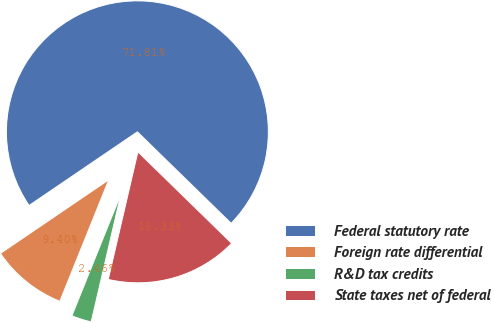Convert chart. <chart><loc_0><loc_0><loc_500><loc_500><pie_chart><fcel>Federal statutory rate<fcel>Foreign rate differential<fcel>R&D tax credits<fcel>State taxes net of federal<nl><fcel>71.81%<fcel>9.4%<fcel>2.46%<fcel>16.33%<nl></chart> 